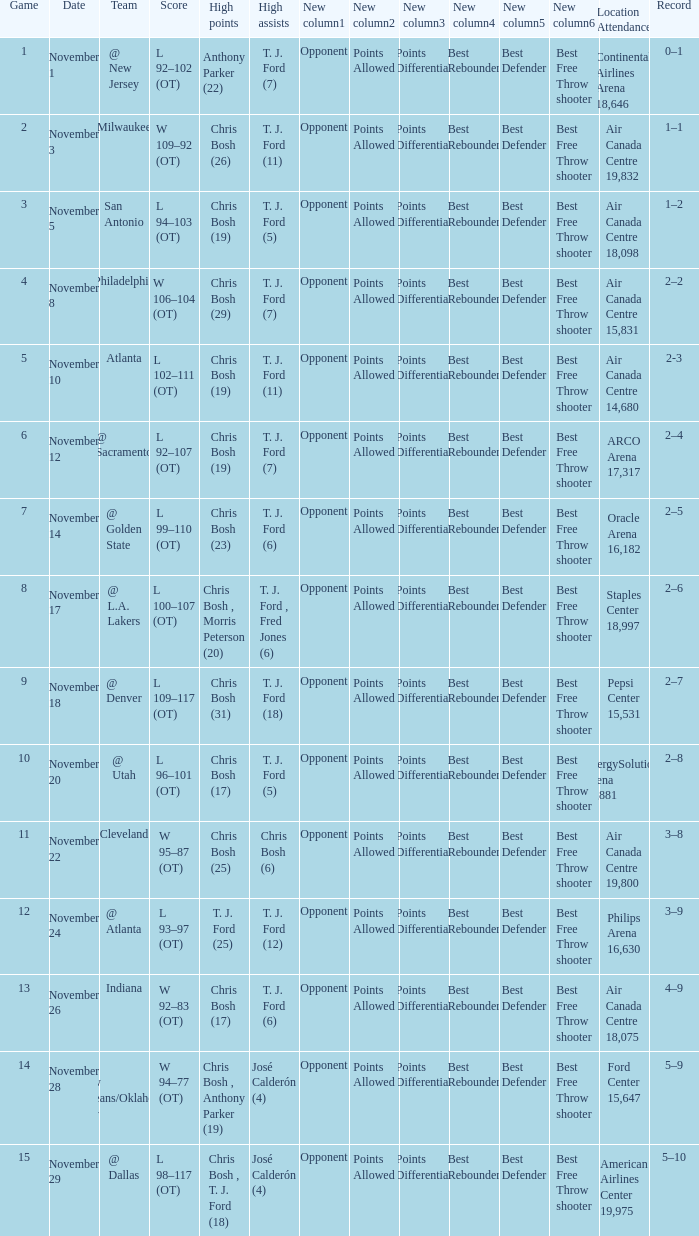What team played on November 28? @ New Orleans/Oklahoma City. 